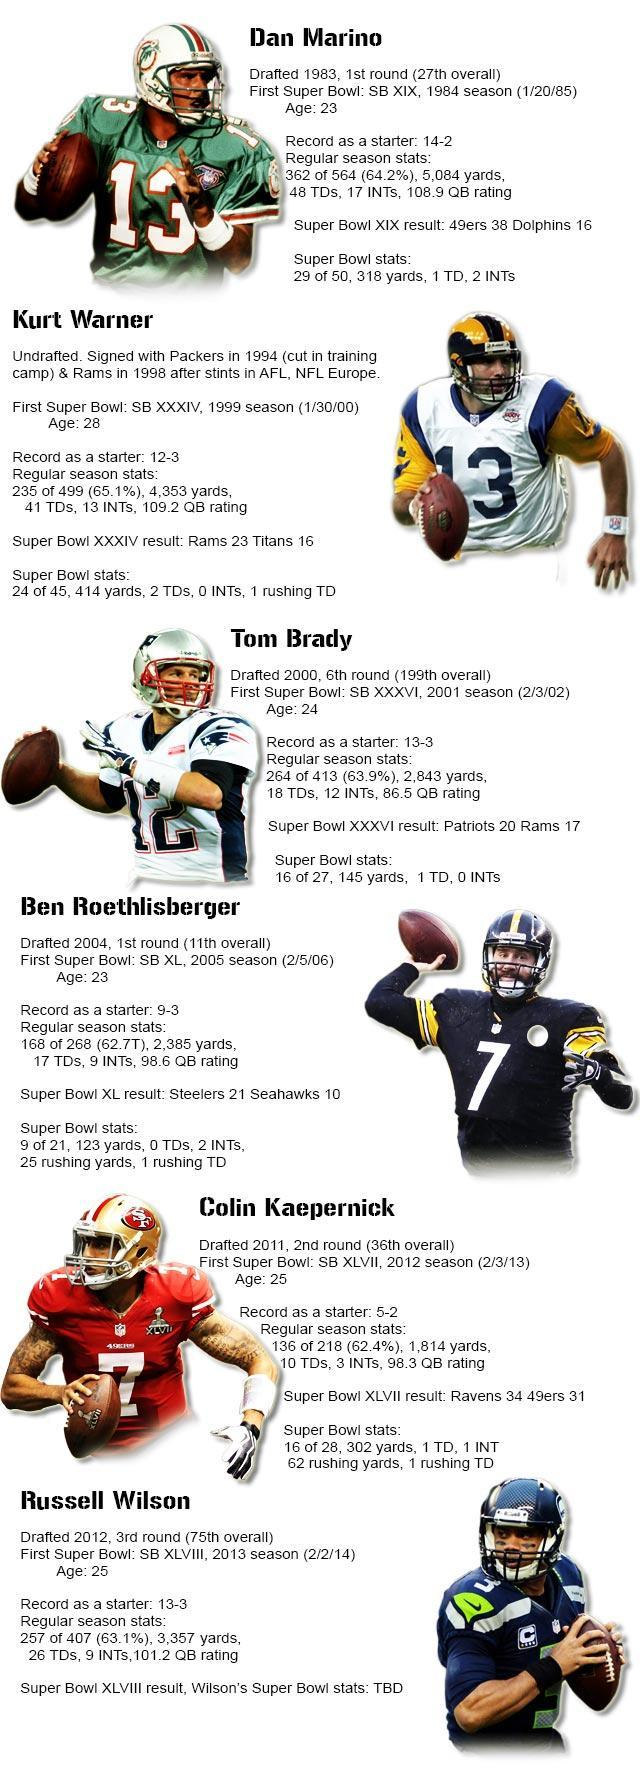Which player played his first super bowl match on 5th February 2006?
Answer the question with a short phrase. Ben Roethlisberger Which player made his first Super Bowl appearance in the 36th edition of the game? Tom Brady How old was Dan Marino when he played his first Super Bowl? 23 Which player's photo is shown at the bottom of the infographic? Russell Wilson The photos of how many players are shown in this infographic? 6 Which of the players played his first super bowl at the age of 28? Kurt Warner Who was the winner in the 2012 season of Super Bowl? Ravens Which player played his first super bowl match in the season when Ravens defeated 49ers 34-31? Colin Kaepernick Which of the players played in the Dolphins vs 49ers super bowl match? Dan Marino In which season of Super bowl did Steelers win against Seahawks? 2005 season 